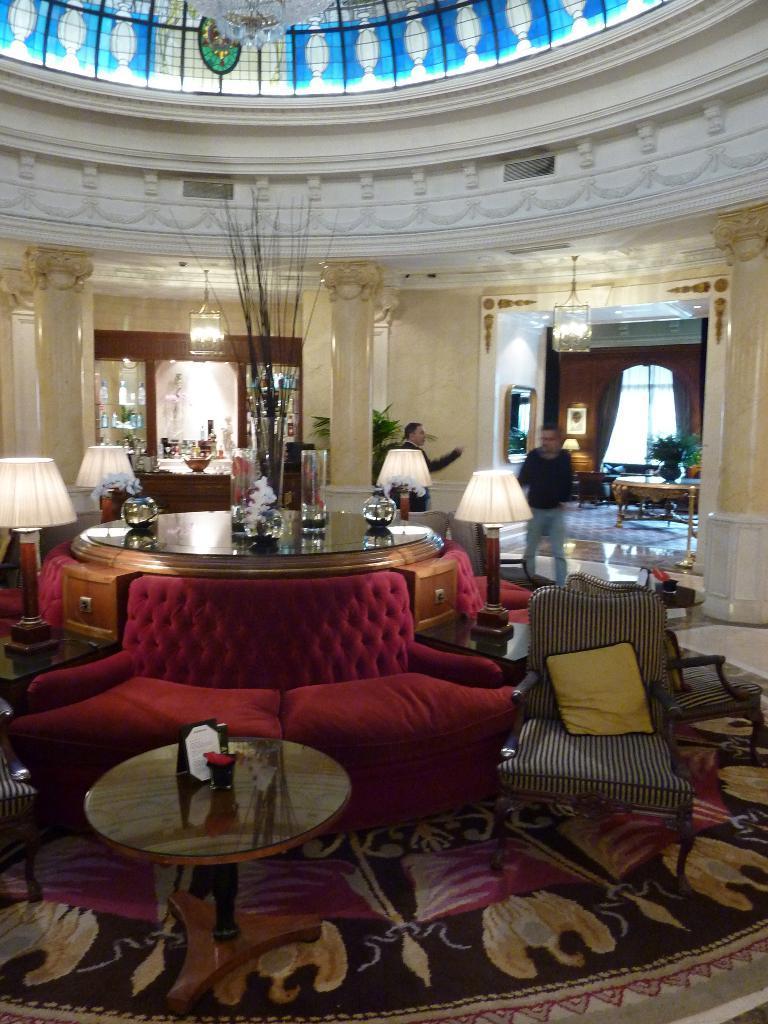Please provide a concise description of this image. In this picture we can see inside view of a building with tables, sofa, chairs and pillows on it and on table we can see jars, lamp, flower vase and in background we can see pillar, window, lamp, curtain,flower pot, two persons. 